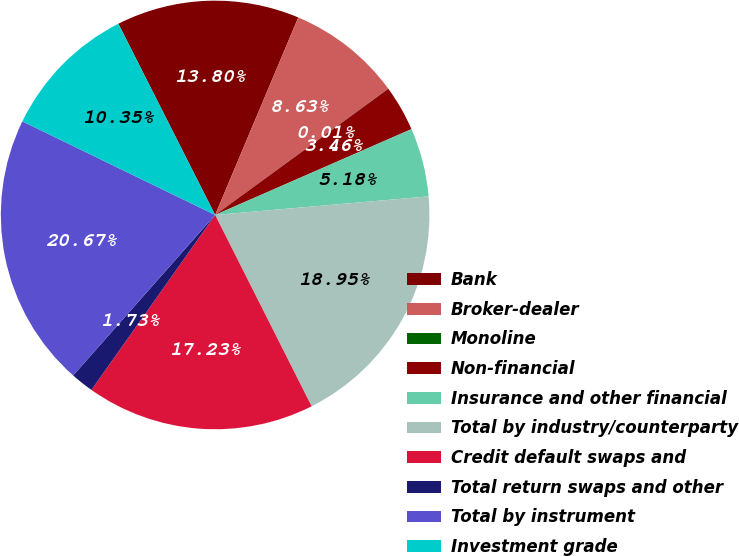Convert chart. <chart><loc_0><loc_0><loc_500><loc_500><pie_chart><fcel>Bank<fcel>Broker-dealer<fcel>Monoline<fcel>Non-financial<fcel>Insurance and other financial<fcel>Total by industry/counterparty<fcel>Credit default swaps and<fcel>Total return swaps and other<fcel>Total by instrument<fcel>Investment grade<nl><fcel>13.8%<fcel>8.63%<fcel>0.01%<fcel>3.46%<fcel>5.18%<fcel>18.95%<fcel>17.23%<fcel>1.73%<fcel>20.67%<fcel>10.35%<nl></chart> 